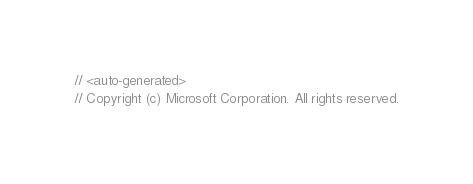Convert code to text. <code><loc_0><loc_0><loc_500><loc_500><_C#_>// <auto-generated>
// Copyright (c) Microsoft Corporation. All rights reserved.</code> 